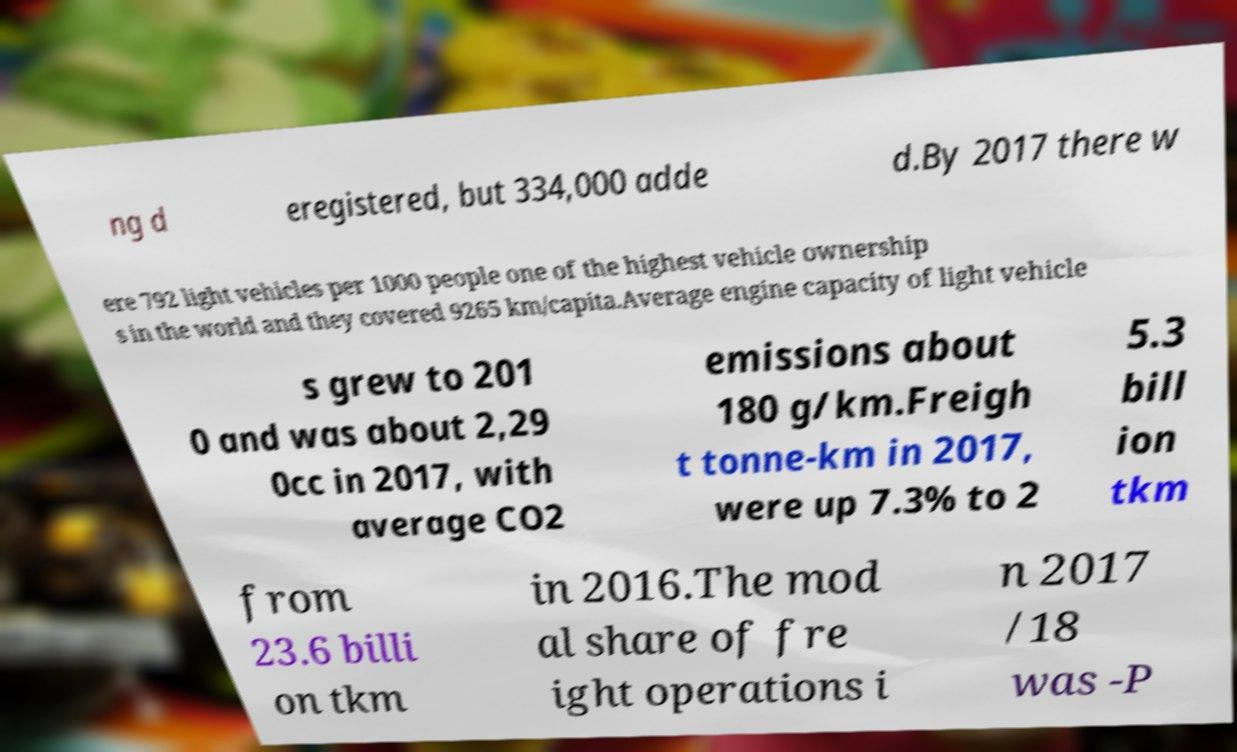There's text embedded in this image that I need extracted. Can you transcribe it verbatim? ng d eregistered, but 334,000 adde d.By 2017 there w ere 792 light vehicles per 1000 people one of the highest vehicle ownership s in the world and they covered 9265 km/capita.Average engine capacity of light vehicle s grew to 201 0 and was about 2,29 0cc in 2017, with average CO2 emissions about 180 g/km.Freigh t tonne-km in 2017, were up 7.3% to 2 5.3 bill ion tkm from 23.6 billi on tkm in 2016.The mod al share of fre ight operations i n 2017 /18 was -P 